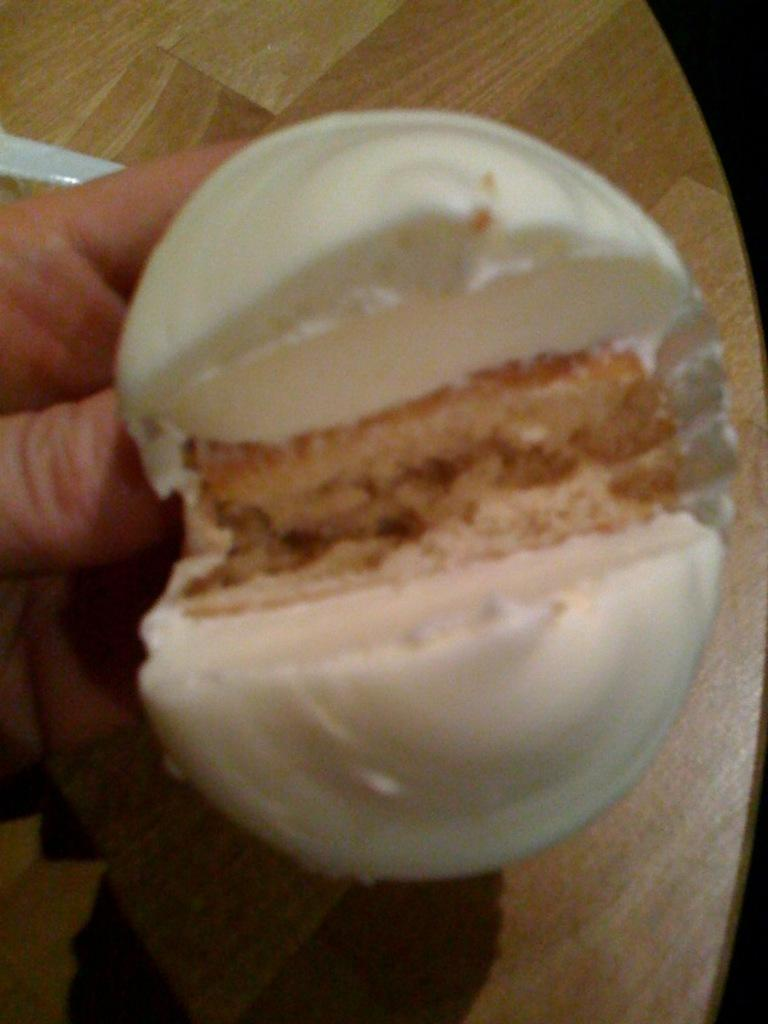What is the person holding in their hand in the image? There is food in the person's hand in the image. Can you describe the appearance of the food? The food has white and brown colors. What can be seen in the background of the image? There is a table in the background of the image. What is the color of the table? The table is brown in color. What is the chance of a zephyr blowing through the room in the image? There is no information about the presence of a zephyr or the likelihood of it blowing through the room in the image. 